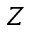<formula> <loc_0><loc_0><loc_500><loc_500>Z</formula> 